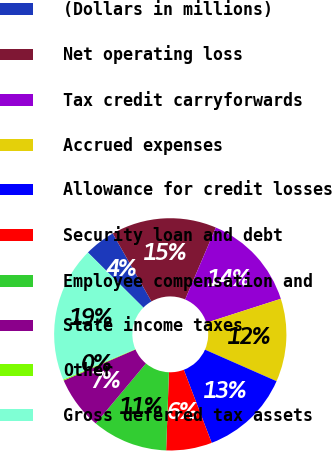<chart> <loc_0><loc_0><loc_500><loc_500><pie_chart><fcel>(Dollars in millions)<fcel>Net operating loss<fcel>Tax credit carryforwards<fcel>Accrued expenses<fcel>Allowance for credit losses<fcel>Security loan and debt<fcel>Employee compensation and<fcel>State income taxes<fcel>Other<fcel>Gross deferred tax assets<nl><fcel>4.3%<fcel>14.67%<fcel>13.63%<fcel>11.56%<fcel>12.59%<fcel>6.37%<fcel>10.52%<fcel>7.41%<fcel>0.15%<fcel>18.81%<nl></chart> 